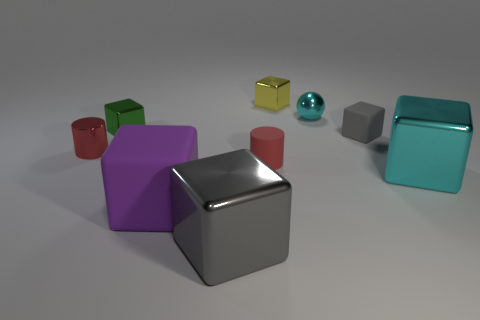Subtract all gray cubes. How many cubes are left? 4 Subtract all tiny gray rubber blocks. How many blocks are left? 5 Subtract all blue cubes. Subtract all brown spheres. How many cubes are left? 6 Add 1 rubber objects. How many objects exist? 10 Subtract all cubes. How many objects are left? 3 Add 4 cyan spheres. How many cyan spheres exist? 5 Subtract 0 green cylinders. How many objects are left? 9 Subtract all small yellow metal balls. Subtract all cyan cubes. How many objects are left? 8 Add 5 red matte objects. How many red matte objects are left? 6 